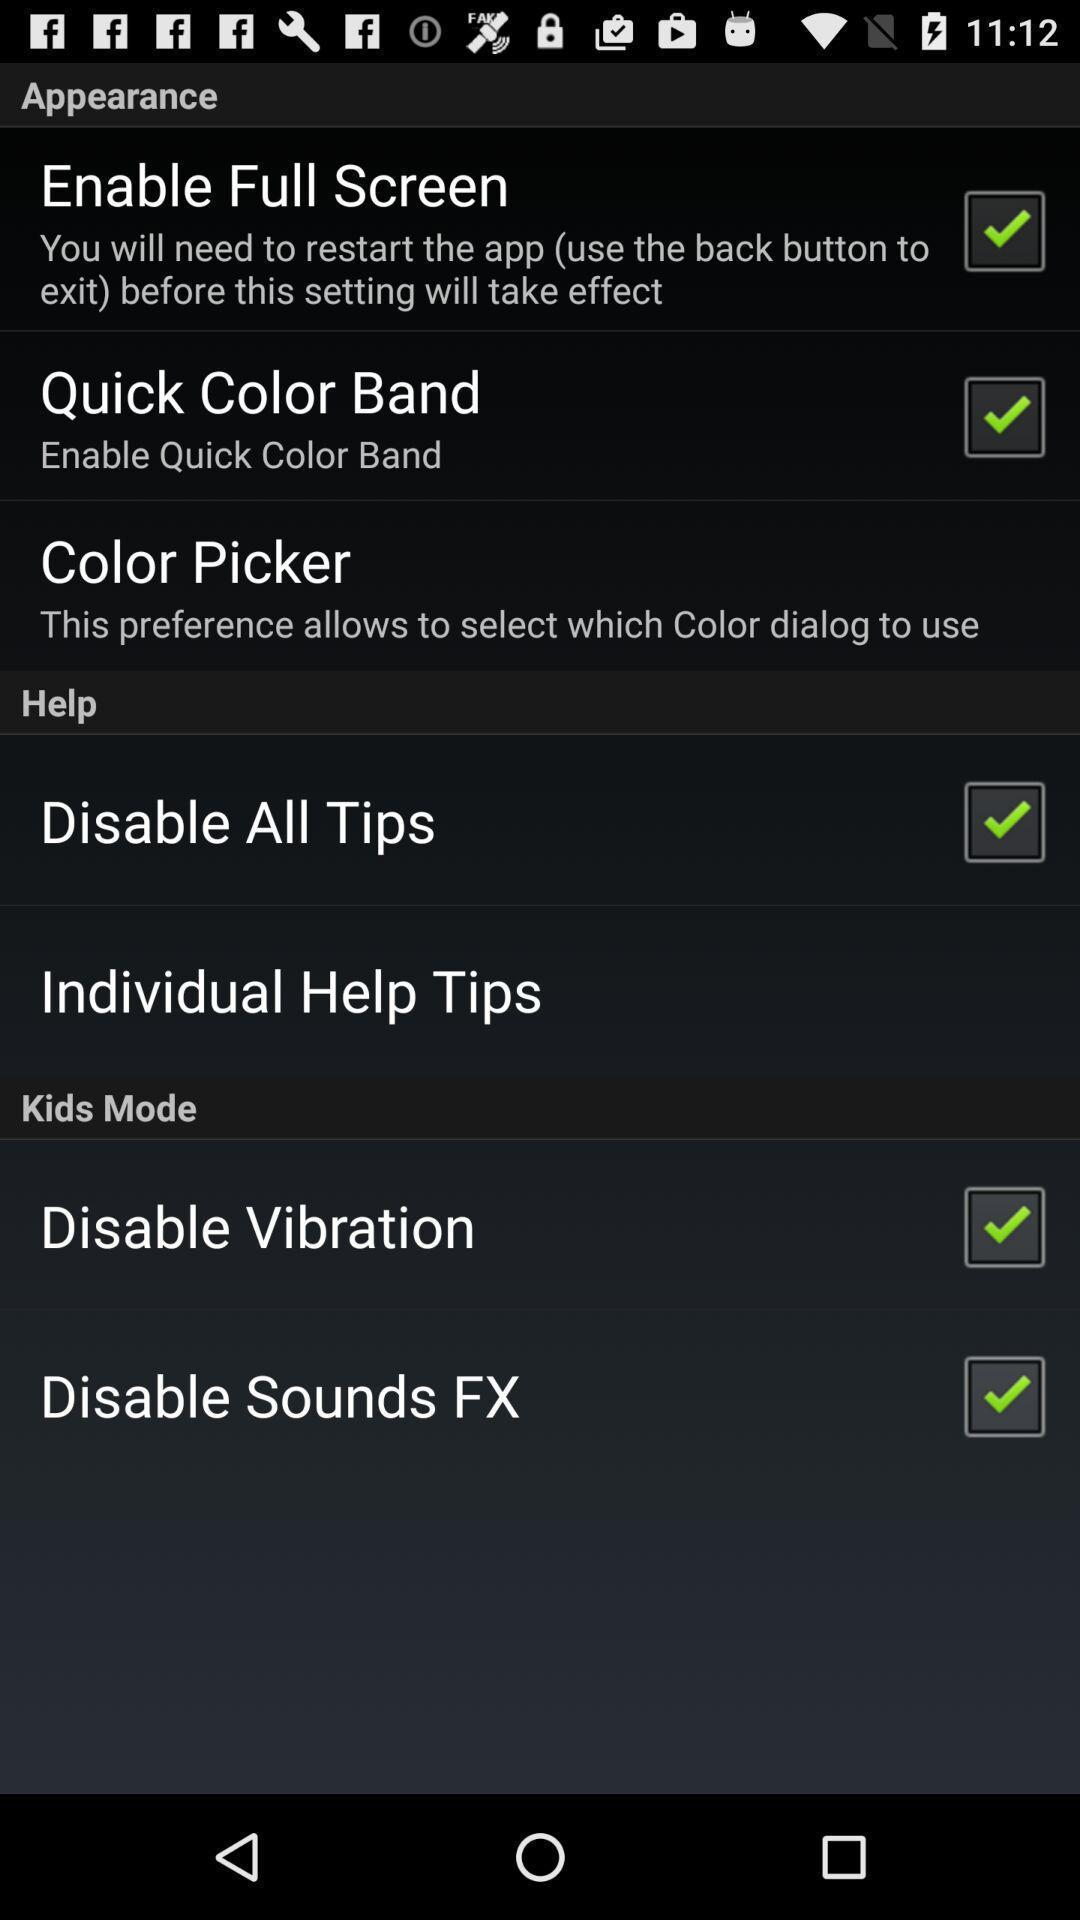How many check boxes are in the Appearance section?
Answer the question using a single word or phrase. 2 